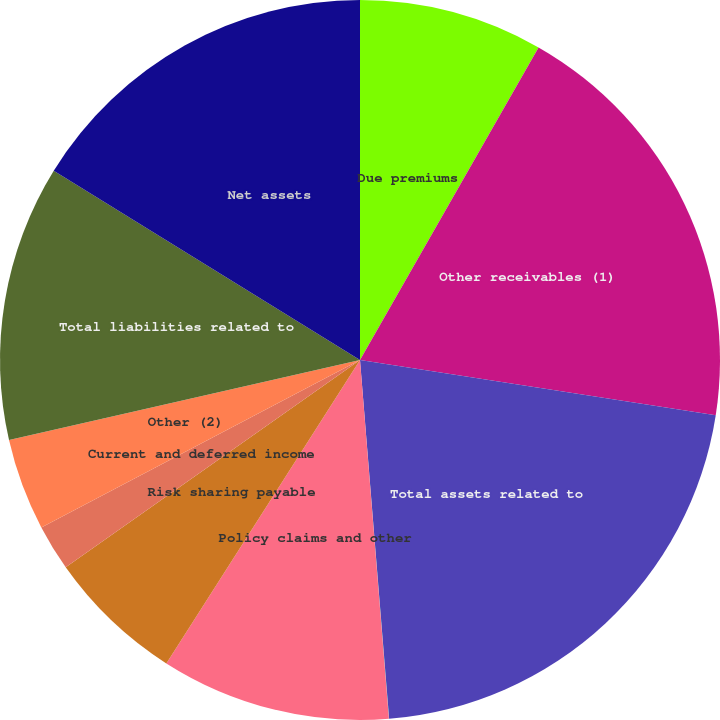<chart> <loc_0><loc_0><loc_500><loc_500><pie_chart><fcel>Due premiums<fcel>Other receivables (1)<fcel>Total assets related to<fcel>Unearned and advance premiums<fcel>Policy claims and other<fcel>Risk sharing payable<fcel>Current and deferred income<fcel>Other (2)<fcel>Total liabilities related to<fcel>Net assets<nl><fcel>8.26%<fcel>19.19%<fcel>21.26%<fcel>0.01%<fcel>10.32%<fcel>6.19%<fcel>2.07%<fcel>4.13%<fcel>12.38%<fcel>16.19%<nl></chart> 